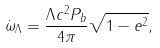Convert formula to latex. <formula><loc_0><loc_0><loc_500><loc_500>\dot { \omega } _ { \Lambda } = \frac { \Lambda c ^ { 2 } P _ { b } } { 4 \pi } \sqrt { 1 - e ^ { 2 } } ,</formula> 